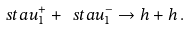<formula> <loc_0><loc_0><loc_500><loc_500>\ s t a u _ { 1 } ^ { + } + \ s t a u _ { 1 } ^ { - } \rightarrow h + h \, .</formula> 